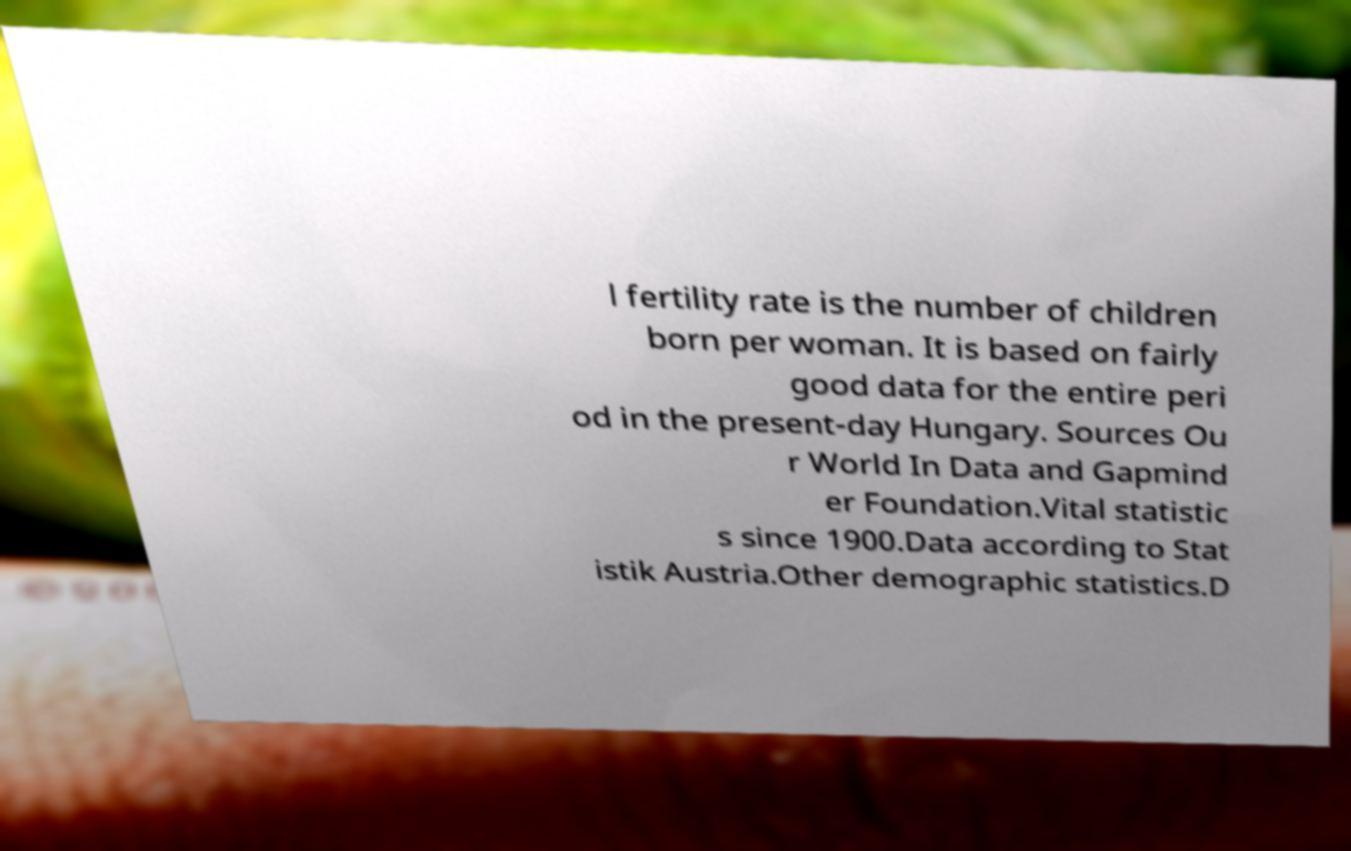I need the written content from this picture converted into text. Can you do that? l fertility rate is the number of children born per woman. It is based on fairly good data for the entire peri od in the present-day Hungary. Sources Ou r World In Data and Gapmind er Foundation.Vital statistic s since 1900.Data according to Stat istik Austria.Other demographic statistics.D 